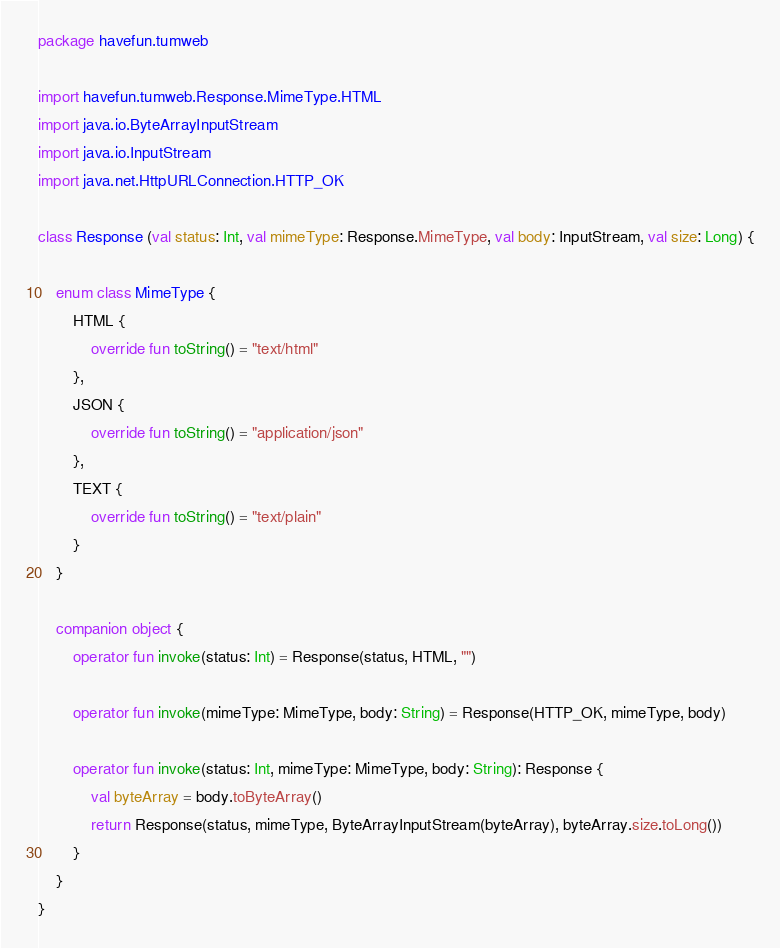Convert code to text. <code><loc_0><loc_0><loc_500><loc_500><_Kotlin_>package havefun.tumweb

import havefun.tumweb.Response.MimeType.HTML
import java.io.ByteArrayInputStream
import java.io.InputStream
import java.net.HttpURLConnection.HTTP_OK

class Response (val status: Int, val mimeType: Response.MimeType, val body: InputStream, val size: Long) {

    enum class MimeType {
        HTML {
            override fun toString() = "text/html"
        },
        JSON {
            override fun toString() = "application/json"
        },
        TEXT {
            override fun toString() = "text/plain"
        }
    }

    companion object {
        operator fun invoke(status: Int) = Response(status, HTML, "")

        operator fun invoke(mimeType: MimeType, body: String) = Response(HTTP_OK, mimeType, body)

        operator fun invoke(status: Int, mimeType: MimeType, body: String): Response {
            val byteArray = body.toByteArray()
            return Response(status, mimeType, ByteArrayInputStream(byteArray), byteArray.size.toLong())
        }
    }
}</code> 